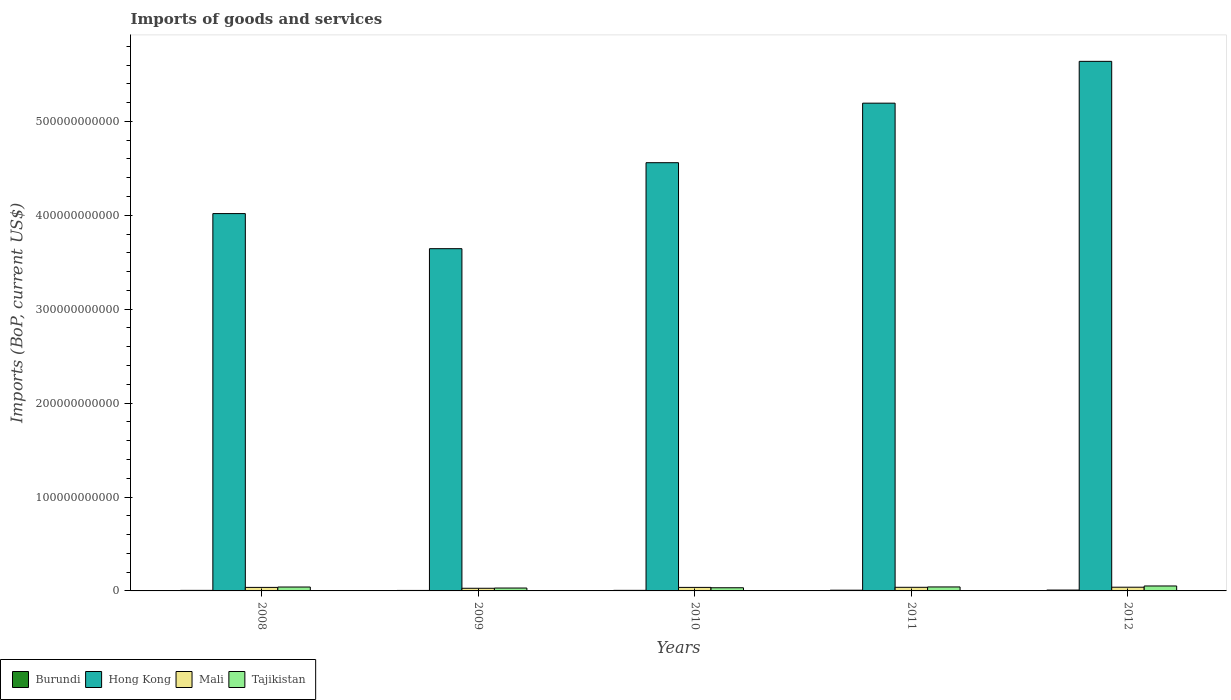How many different coloured bars are there?
Offer a terse response. 4. Are the number of bars on each tick of the X-axis equal?
Offer a very short reply. Yes. How many bars are there on the 4th tick from the left?
Make the answer very short. 4. How many bars are there on the 5th tick from the right?
Provide a short and direct response. 4. What is the amount spent on imports in Hong Kong in 2008?
Offer a terse response. 4.02e+11. Across all years, what is the maximum amount spent on imports in Mali?
Offer a terse response. 3.95e+09. Across all years, what is the minimum amount spent on imports in Hong Kong?
Give a very brief answer. 3.64e+11. What is the total amount spent on imports in Hong Kong in the graph?
Offer a terse response. 2.31e+12. What is the difference between the amount spent on imports in Burundi in 2008 and that in 2011?
Ensure brevity in your answer.  -1.71e+08. What is the difference between the amount spent on imports in Mali in 2008 and the amount spent on imports in Hong Kong in 2010?
Give a very brief answer. -4.52e+11. What is the average amount spent on imports in Mali per year?
Provide a succinct answer. 3.62e+09. In the year 2008, what is the difference between the amount spent on imports in Mali and amount spent on imports in Hong Kong?
Your answer should be compact. -3.98e+11. What is the ratio of the amount spent on imports in Burundi in 2008 to that in 2009?
Offer a terse response. 1.14. Is the difference between the amount spent on imports in Mali in 2010 and 2012 greater than the difference between the amount spent on imports in Hong Kong in 2010 and 2012?
Ensure brevity in your answer.  Yes. What is the difference between the highest and the second highest amount spent on imports in Mali?
Keep it short and to the point. 1.03e+08. What is the difference between the highest and the lowest amount spent on imports in Hong Kong?
Give a very brief answer. 1.99e+11. In how many years, is the amount spent on imports in Mali greater than the average amount spent on imports in Mali taken over all years?
Provide a short and direct response. 4. Is the sum of the amount spent on imports in Hong Kong in 2009 and 2010 greater than the maximum amount spent on imports in Tajikistan across all years?
Your answer should be compact. Yes. Is it the case that in every year, the sum of the amount spent on imports in Tajikistan and amount spent on imports in Mali is greater than the sum of amount spent on imports in Burundi and amount spent on imports in Hong Kong?
Make the answer very short. No. What does the 4th bar from the left in 2011 represents?
Provide a short and direct response. Tajikistan. What does the 4th bar from the right in 2011 represents?
Your answer should be very brief. Burundi. How many bars are there?
Offer a very short reply. 20. Are all the bars in the graph horizontal?
Provide a short and direct response. No. What is the difference between two consecutive major ticks on the Y-axis?
Your response must be concise. 1.00e+11. Does the graph contain grids?
Your answer should be compact. No. What is the title of the graph?
Provide a succinct answer. Imports of goods and services. What is the label or title of the Y-axis?
Offer a very short reply. Imports (BoP, current US$). What is the Imports (BoP, current US$) in Burundi in 2008?
Your response must be concise. 5.94e+08. What is the Imports (BoP, current US$) in Hong Kong in 2008?
Your answer should be compact. 4.02e+11. What is the Imports (BoP, current US$) of Mali in 2008?
Offer a terse response. 3.76e+09. What is the Imports (BoP, current US$) of Tajikistan in 2008?
Your answer should be compact. 4.15e+09. What is the Imports (BoP, current US$) in Burundi in 2009?
Ensure brevity in your answer.  5.20e+08. What is the Imports (BoP, current US$) in Hong Kong in 2009?
Provide a succinct answer. 3.64e+11. What is the Imports (BoP, current US$) in Mali in 2009?
Give a very brief answer. 2.81e+09. What is the Imports (BoP, current US$) in Tajikistan in 2009?
Offer a terse response. 3.06e+09. What is the Imports (BoP, current US$) of Burundi in 2010?
Your answer should be compact. 6.07e+08. What is the Imports (BoP, current US$) in Hong Kong in 2010?
Your answer should be very brief. 4.56e+11. What is the Imports (BoP, current US$) of Mali in 2010?
Make the answer very short. 3.74e+09. What is the Imports (BoP, current US$) in Tajikistan in 2010?
Make the answer very short. 3.36e+09. What is the Imports (BoP, current US$) in Burundi in 2011?
Ensure brevity in your answer.  7.65e+08. What is the Imports (BoP, current US$) in Hong Kong in 2011?
Your answer should be compact. 5.19e+11. What is the Imports (BoP, current US$) of Mali in 2011?
Your response must be concise. 3.85e+09. What is the Imports (BoP, current US$) in Tajikistan in 2011?
Provide a succinct answer. 4.24e+09. What is the Imports (BoP, current US$) in Burundi in 2012?
Your answer should be very brief. 9.23e+08. What is the Imports (BoP, current US$) in Hong Kong in 2012?
Keep it short and to the point. 5.64e+11. What is the Imports (BoP, current US$) in Mali in 2012?
Provide a short and direct response. 3.95e+09. What is the Imports (BoP, current US$) of Tajikistan in 2012?
Provide a succinct answer. 5.27e+09. Across all years, what is the maximum Imports (BoP, current US$) in Burundi?
Provide a short and direct response. 9.23e+08. Across all years, what is the maximum Imports (BoP, current US$) of Hong Kong?
Your answer should be compact. 5.64e+11. Across all years, what is the maximum Imports (BoP, current US$) in Mali?
Offer a terse response. 3.95e+09. Across all years, what is the maximum Imports (BoP, current US$) in Tajikistan?
Keep it short and to the point. 5.27e+09. Across all years, what is the minimum Imports (BoP, current US$) of Burundi?
Your answer should be very brief. 5.20e+08. Across all years, what is the minimum Imports (BoP, current US$) in Hong Kong?
Give a very brief answer. 3.64e+11. Across all years, what is the minimum Imports (BoP, current US$) of Mali?
Your answer should be very brief. 2.81e+09. Across all years, what is the minimum Imports (BoP, current US$) of Tajikistan?
Offer a very short reply. 3.06e+09. What is the total Imports (BoP, current US$) of Burundi in the graph?
Your answer should be very brief. 3.41e+09. What is the total Imports (BoP, current US$) of Hong Kong in the graph?
Your answer should be compact. 2.31e+12. What is the total Imports (BoP, current US$) of Mali in the graph?
Ensure brevity in your answer.  1.81e+1. What is the total Imports (BoP, current US$) of Tajikistan in the graph?
Offer a very short reply. 2.01e+1. What is the difference between the Imports (BoP, current US$) in Burundi in 2008 and that in 2009?
Offer a terse response. 7.46e+07. What is the difference between the Imports (BoP, current US$) of Hong Kong in 2008 and that in 2009?
Keep it short and to the point. 3.74e+1. What is the difference between the Imports (BoP, current US$) in Mali in 2008 and that in 2009?
Ensure brevity in your answer.  9.45e+08. What is the difference between the Imports (BoP, current US$) in Tajikistan in 2008 and that in 2009?
Ensure brevity in your answer.  1.09e+09. What is the difference between the Imports (BoP, current US$) of Burundi in 2008 and that in 2010?
Ensure brevity in your answer.  -1.25e+07. What is the difference between the Imports (BoP, current US$) of Hong Kong in 2008 and that in 2010?
Make the answer very short. -5.42e+1. What is the difference between the Imports (BoP, current US$) of Mali in 2008 and that in 2010?
Provide a succinct answer. 1.23e+07. What is the difference between the Imports (BoP, current US$) in Tajikistan in 2008 and that in 2010?
Your answer should be very brief. 7.90e+08. What is the difference between the Imports (BoP, current US$) in Burundi in 2008 and that in 2011?
Offer a terse response. -1.71e+08. What is the difference between the Imports (BoP, current US$) of Hong Kong in 2008 and that in 2011?
Offer a terse response. -1.18e+11. What is the difference between the Imports (BoP, current US$) of Mali in 2008 and that in 2011?
Your answer should be compact. -9.39e+07. What is the difference between the Imports (BoP, current US$) in Tajikistan in 2008 and that in 2011?
Provide a short and direct response. -8.48e+07. What is the difference between the Imports (BoP, current US$) in Burundi in 2008 and that in 2012?
Offer a very short reply. -3.28e+08. What is the difference between the Imports (BoP, current US$) in Hong Kong in 2008 and that in 2012?
Offer a very short reply. -1.62e+11. What is the difference between the Imports (BoP, current US$) in Mali in 2008 and that in 2012?
Your answer should be compact. -1.97e+08. What is the difference between the Imports (BoP, current US$) in Tajikistan in 2008 and that in 2012?
Provide a succinct answer. -1.12e+09. What is the difference between the Imports (BoP, current US$) in Burundi in 2009 and that in 2010?
Keep it short and to the point. -8.71e+07. What is the difference between the Imports (BoP, current US$) of Hong Kong in 2009 and that in 2010?
Offer a very short reply. -9.16e+1. What is the difference between the Imports (BoP, current US$) of Mali in 2009 and that in 2010?
Make the answer very short. -9.33e+08. What is the difference between the Imports (BoP, current US$) of Tajikistan in 2009 and that in 2010?
Ensure brevity in your answer.  -3.02e+08. What is the difference between the Imports (BoP, current US$) of Burundi in 2009 and that in 2011?
Offer a terse response. -2.46e+08. What is the difference between the Imports (BoP, current US$) in Hong Kong in 2009 and that in 2011?
Your response must be concise. -1.55e+11. What is the difference between the Imports (BoP, current US$) in Mali in 2009 and that in 2011?
Offer a terse response. -1.04e+09. What is the difference between the Imports (BoP, current US$) in Tajikistan in 2009 and that in 2011?
Make the answer very short. -1.18e+09. What is the difference between the Imports (BoP, current US$) in Burundi in 2009 and that in 2012?
Offer a very short reply. -4.03e+08. What is the difference between the Imports (BoP, current US$) of Hong Kong in 2009 and that in 2012?
Keep it short and to the point. -1.99e+11. What is the difference between the Imports (BoP, current US$) of Mali in 2009 and that in 2012?
Your answer should be very brief. -1.14e+09. What is the difference between the Imports (BoP, current US$) in Tajikistan in 2009 and that in 2012?
Your answer should be very brief. -2.21e+09. What is the difference between the Imports (BoP, current US$) of Burundi in 2010 and that in 2011?
Your response must be concise. -1.59e+08. What is the difference between the Imports (BoP, current US$) in Hong Kong in 2010 and that in 2011?
Give a very brief answer. -6.34e+1. What is the difference between the Imports (BoP, current US$) in Mali in 2010 and that in 2011?
Offer a terse response. -1.06e+08. What is the difference between the Imports (BoP, current US$) in Tajikistan in 2010 and that in 2011?
Your answer should be very brief. -8.75e+08. What is the difference between the Imports (BoP, current US$) in Burundi in 2010 and that in 2012?
Your response must be concise. -3.16e+08. What is the difference between the Imports (BoP, current US$) of Hong Kong in 2010 and that in 2012?
Give a very brief answer. -1.08e+11. What is the difference between the Imports (BoP, current US$) in Mali in 2010 and that in 2012?
Give a very brief answer. -2.09e+08. What is the difference between the Imports (BoP, current US$) of Tajikistan in 2010 and that in 2012?
Provide a short and direct response. -1.91e+09. What is the difference between the Imports (BoP, current US$) of Burundi in 2011 and that in 2012?
Your answer should be compact. -1.57e+08. What is the difference between the Imports (BoP, current US$) of Hong Kong in 2011 and that in 2012?
Your response must be concise. -4.45e+1. What is the difference between the Imports (BoP, current US$) of Mali in 2011 and that in 2012?
Provide a short and direct response. -1.03e+08. What is the difference between the Imports (BoP, current US$) in Tajikistan in 2011 and that in 2012?
Provide a short and direct response. -1.03e+09. What is the difference between the Imports (BoP, current US$) in Burundi in 2008 and the Imports (BoP, current US$) in Hong Kong in 2009?
Your answer should be compact. -3.64e+11. What is the difference between the Imports (BoP, current US$) of Burundi in 2008 and the Imports (BoP, current US$) of Mali in 2009?
Provide a succinct answer. -2.22e+09. What is the difference between the Imports (BoP, current US$) of Burundi in 2008 and the Imports (BoP, current US$) of Tajikistan in 2009?
Ensure brevity in your answer.  -2.47e+09. What is the difference between the Imports (BoP, current US$) in Hong Kong in 2008 and the Imports (BoP, current US$) in Mali in 2009?
Give a very brief answer. 3.99e+11. What is the difference between the Imports (BoP, current US$) in Hong Kong in 2008 and the Imports (BoP, current US$) in Tajikistan in 2009?
Provide a succinct answer. 3.99e+11. What is the difference between the Imports (BoP, current US$) in Mali in 2008 and the Imports (BoP, current US$) in Tajikistan in 2009?
Offer a very short reply. 6.95e+08. What is the difference between the Imports (BoP, current US$) in Burundi in 2008 and the Imports (BoP, current US$) in Hong Kong in 2010?
Make the answer very short. -4.55e+11. What is the difference between the Imports (BoP, current US$) in Burundi in 2008 and the Imports (BoP, current US$) in Mali in 2010?
Give a very brief answer. -3.15e+09. What is the difference between the Imports (BoP, current US$) in Burundi in 2008 and the Imports (BoP, current US$) in Tajikistan in 2010?
Keep it short and to the point. -2.77e+09. What is the difference between the Imports (BoP, current US$) in Hong Kong in 2008 and the Imports (BoP, current US$) in Mali in 2010?
Your answer should be compact. 3.98e+11. What is the difference between the Imports (BoP, current US$) of Hong Kong in 2008 and the Imports (BoP, current US$) of Tajikistan in 2010?
Offer a terse response. 3.98e+11. What is the difference between the Imports (BoP, current US$) of Mali in 2008 and the Imports (BoP, current US$) of Tajikistan in 2010?
Give a very brief answer. 3.93e+08. What is the difference between the Imports (BoP, current US$) in Burundi in 2008 and the Imports (BoP, current US$) in Hong Kong in 2011?
Ensure brevity in your answer.  -5.19e+11. What is the difference between the Imports (BoP, current US$) of Burundi in 2008 and the Imports (BoP, current US$) of Mali in 2011?
Ensure brevity in your answer.  -3.26e+09. What is the difference between the Imports (BoP, current US$) of Burundi in 2008 and the Imports (BoP, current US$) of Tajikistan in 2011?
Make the answer very short. -3.65e+09. What is the difference between the Imports (BoP, current US$) of Hong Kong in 2008 and the Imports (BoP, current US$) of Mali in 2011?
Provide a short and direct response. 3.98e+11. What is the difference between the Imports (BoP, current US$) of Hong Kong in 2008 and the Imports (BoP, current US$) of Tajikistan in 2011?
Give a very brief answer. 3.98e+11. What is the difference between the Imports (BoP, current US$) of Mali in 2008 and the Imports (BoP, current US$) of Tajikistan in 2011?
Provide a succinct answer. -4.82e+08. What is the difference between the Imports (BoP, current US$) of Burundi in 2008 and the Imports (BoP, current US$) of Hong Kong in 2012?
Offer a very short reply. -5.63e+11. What is the difference between the Imports (BoP, current US$) in Burundi in 2008 and the Imports (BoP, current US$) in Mali in 2012?
Provide a succinct answer. -3.36e+09. What is the difference between the Imports (BoP, current US$) of Burundi in 2008 and the Imports (BoP, current US$) of Tajikistan in 2012?
Offer a very short reply. -4.68e+09. What is the difference between the Imports (BoP, current US$) in Hong Kong in 2008 and the Imports (BoP, current US$) in Mali in 2012?
Give a very brief answer. 3.98e+11. What is the difference between the Imports (BoP, current US$) of Hong Kong in 2008 and the Imports (BoP, current US$) of Tajikistan in 2012?
Keep it short and to the point. 3.97e+11. What is the difference between the Imports (BoP, current US$) in Mali in 2008 and the Imports (BoP, current US$) in Tajikistan in 2012?
Keep it short and to the point. -1.52e+09. What is the difference between the Imports (BoP, current US$) of Burundi in 2009 and the Imports (BoP, current US$) of Hong Kong in 2010?
Make the answer very short. -4.55e+11. What is the difference between the Imports (BoP, current US$) in Burundi in 2009 and the Imports (BoP, current US$) in Mali in 2010?
Your response must be concise. -3.23e+09. What is the difference between the Imports (BoP, current US$) in Burundi in 2009 and the Imports (BoP, current US$) in Tajikistan in 2010?
Your answer should be compact. -2.84e+09. What is the difference between the Imports (BoP, current US$) in Hong Kong in 2009 and the Imports (BoP, current US$) in Mali in 2010?
Keep it short and to the point. 3.61e+11. What is the difference between the Imports (BoP, current US$) of Hong Kong in 2009 and the Imports (BoP, current US$) of Tajikistan in 2010?
Your answer should be compact. 3.61e+11. What is the difference between the Imports (BoP, current US$) in Mali in 2009 and the Imports (BoP, current US$) in Tajikistan in 2010?
Offer a terse response. -5.53e+08. What is the difference between the Imports (BoP, current US$) of Burundi in 2009 and the Imports (BoP, current US$) of Hong Kong in 2011?
Ensure brevity in your answer.  -5.19e+11. What is the difference between the Imports (BoP, current US$) of Burundi in 2009 and the Imports (BoP, current US$) of Mali in 2011?
Offer a very short reply. -3.33e+09. What is the difference between the Imports (BoP, current US$) of Burundi in 2009 and the Imports (BoP, current US$) of Tajikistan in 2011?
Ensure brevity in your answer.  -3.72e+09. What is the difference between the Imports (BoP, current US$) in Hong Kong in 2009 and the Imports (BoP, current US$) in Mali in 2011?
Keep it short and to the point. 3.61e+11. What is the difference between the Imports (BoP, current US$) of Hong Kong in 2009 and the Imports (BoP, current US$) of Tajikistan in 2011?
Give a very brief answer. 3.60e+11. What is the difference between the Imports (BoP, current US$) in Mali in 2009 and the Imports (BoP, current US$) in Tajikistan in 2011?
Keep it short and to the point. -1.43e+09. What is the difference between the Imports (BoP, current US$) in Burundi in 2009 and the Imports (BoP, current US$) in Hong Kong in 2012?
Give a very brief answer. -5.63e+11. What is the difference between the Imports (BoP, current US$) in Burundi in 2009 and the Imports (BoP, current US$) in Mali in 2012?
Your answer should be very brief. -3.43e+09. What is the difference between the Imports (BoP, current US$) of Burundi in 2009 and the Imports (BoP, current US$) of Tajikistan in 2012?
Your answer should be compact. -4.75e+09. What is the difference between the Imports (BoP, current US$) in Hong Kong in 2009 and the Imports (BoP, current US$) in Mali in 2012?
Your answer should be very brief. 3.60e+11. What is the difference between the Imports (BoP, current US$) in Hong Kong in 2009 and the Imports (BoP, current US$) in Tajikistan in 2012?
Offer a very short reply. 3.59e+11. What is the difference between the Imports (BoP, current US$) of Mali in 2009 and the Imports (BoP, current US$) of Tajikistan in 2012?
Offer a terse response. -2.46e+09. What is the difference between the Imports (BoP, current US$) of Burundi in 2010 and the Imports (BoP, current US$) of Hong Kong in 2011?
Give a very brief answer. -5.19e+11. What is the difference between the Imports (BoP, current US$) in Burundi in 2010 and the Imports (BoP, current US$) in Mali in 2011?
Provide a short and direct response. -3.24e+09. What is the difference between the Imports (BoP, current US$) in Burundi in 2010 and the Imports (BoP, current US$) in Tajikistan in 2011?
Your answer should be compact. -3.63e+09. What is the difference between the Imports (BoP, current US$) of Hong Kong in 2010 and the Imports (BoP, current US$) of Mali in 2011?
Provide a succinct answer. 4.52e+11. What is the difference between the Imports (BoP, current US$) in Hong Kong in 2010 and the Imports (BoP, current US$) in Tajikistan in 2011?
Your answer should be very brief. 4.52e+11. What is the difference between the Imports (BoP, current US$) in Mali in 2010 and the Imports (BoP, current US$) in Tajikistan in 2011?
Make the answer very short. -4.95e+08. What is the difference between the Imports (BoP, current US$) in Burundi in 2010 and the Imports (BoP, current US$) in Hong Kong in 2012?
Provide a short and direct response. -5.63e+11. What is the difference between the Imports (BoP, current US$) of Burundi in 2010 and the Imports (BoP, current US$) of Mali in 2012?
Make the answer very short. -3.35e+09. What is the difference between the Imports (BoP, current US$) of Burundi in 2010 and the Imports (BoP, current US$) of Tajikistan in 2012?
Make the answer very short. -4.67e+09. What is the difference between the Imports (BoP, current US$) of Hong Kong in 2010 and the Imports (BoP, current US$) of Mali in 2012?
Provide a short and direct response. 4.52e+11. What is the difference between the Imports (BoP, current US$) in Hong Kong in 2010 and the Imports (BoP, current US$) in Tajikistan in 2012?
Your response must be concise. 4.51e+11. What is the difference between the Imports (BoP, current US$) of Mali in 2010 and the Imports (BoP, current US$) of Tajikistan in 2012?
Offer a terse response. -1.53e+09. What is the difference between the Imports (BoP, current US$) of Burundi in 2011 and the Imports (BoP, current US$) of Hong Kong in 2012?
Provide a short and direct response. -5.63e+11. What is the difference between the Imports (BoP, current US$) in Burundi in 2011 and the Imports (BoP, current US$) in Mali in 2012?
Ensure brevity in your answer.  -3.19e+09. What is the difference between the Imports (BoP, current US$) of Burundi in 2011 and the Imports (BoP, current US$) of Tajikistan in 2012?
Your answer should be very brief. -4.51e+09. What is the difference between the Imports (BoP, current US$) in Hong Kong in 2011 and the Imports (BoP, current US$) in Mali in 2012?
Your response must be concise. 5.15e+11. What is the difference between the Imports (BoP, current US$) of Hong Kong in 2011 and the Imports (BoP, current US$) of Tajikistan in 2012?
Your answer should be compact. 5.14e+11. What is the difference between the Imports (BoP, current US$) in Mali in 2011 and the Imports (BoP, current US$) in Tajikistan in 2012?
Your response must be concise. -1.42e+09. What is the average Imports (BoP, current US$) of Burundi per year?
Provide a succinct answer. 6.82e+08. What is the average Imports (BoP, current US$) in Hong Kong per year?
Your response must be concise. 4.61e+11. What is the average Imports (BoP, current US$) of Mali per year?
Keep it short and to the point. 3.62e+09. What is the average Imports (BoP, current US$) of Tajikistan per year?
Keep it short and to the point. 4.02e+09. In the year 2008, what is the difference between the Imports (BoP, current US$) of Burundi and Imports (BoP, current US$) of Hong Kong?
Your answer should be very brief. -4.01e+11. In the year 2008, what is the difference between the Imports (BoP, current US$) of Burundi and Imports (BoP, current US$) of Mali?
Offer a very short reply. -3.16e+09. In the year 2008, what is the difference between the Imports (BoP, current US$) in Burundi and Imports (BoP, current US$) in Tajikistan?
Your answer should be compact. -3.56e+09. In the year 2008, what is the difference between the Imports (BoP, current US$) of Hong Kong and Imports (BoP, current US$) of Mali?
Provide a succinct answer. 3.98e+11. In the year 2008, what is the difference between the Imports (BoP, current US$) in Hong Kong and Imports (BoP, current US$) in Tajikistan?
Make the answer very short. 3.98e+11. In the year 2008, what is the difference between the Imports (BoP, current US$) in Mali and Imports (BoP, current US$) in Tajikistan?
Offer a very short reply. -3.97e+08. In the year 2009, what is the difference between the Imports (BoP, current US$) in Burundi and Imports (BoP, current US$) in Hong Kong?
Your answer should be compact. -3.64e+11. In the year 2009, what is the difference between the Imports (BoP, current US$) in Burundi and Imports (BoP, current US$) in Mali?
Ensure brevity in your answer.  -2.29e+09. In the year 2009, what is the difference between the Imports (BoP, current US$) of Burundi and Imports (BoP, current US$) of Tajikistan?
Keep it short and to the point. -2.54e+09. In the year 2009, what is the difference between the Imports (BoP, current US$) in Hong Kong and Imports (BoP, current US$) in Mali?
Keep it short and to the point. 3.62e+11. In the year 2009, what is the difference between the Imports (BoP, current US$) of Hong Kong and Imports (BoP, current US$) of Tajikistan?
Your answer should be very brief. 3.61e+11. In the year 2009, what is the difference between the Imports (BoP, current US$) of Mali and Imports (BoP, current US$) of Tajikistan?
Offer a very short reply. -2.50e+08. In the year 2010, what is the difference between the Imports (BoP, current US$) of Burundi and Imports (BoP, current US$) of Hong Kong?
Your answer should be compact. -4.55e+11. In the year 2010, what is the difference between the Imports (BoP, current US$) in Burundi and Imports (BoP, current US$) in Mali?
Provide a succinct answer. -3.14e+09. In the year 2010, what is the difference between the Imports (BoP, current US$) in Burundi and Imports (BoP, current US$) in Tajikistan?
Make the answer very short. -2.76e+09. In the year 2010, what is the difference between the Imports (BoP, current US$) in Hong Kong and Imports (BoP, current US$) in Mali?
Make the answer very short. 4.52e+11. In the year 2010, what is the difference between the Imports (BoP, current US$) of Hong Kong and Imports (BoP, current US$) of Tajikistan?
Your answer should be compact. 4.53e+11. In the year 2010, what is the difference between the Imports (BoP, current US$) of Mali and Imports (BoP, current US$) of Tajikistan?
Offer a very short reply. 3.80e+08. In the year 2011, what is the difference between the Imports (BoP, current US$) in Burundi and Imports (BoP, current US$) in Hong Kong?
Your response must be concise. -5.19e+11. In the year 2011, what is the difference between the Imports (BoP, current US$) in Burundi and Imports (BoP, current US$) in Mali?
Keep it short and to the point. -3.09e+09. In the year 2011, what is the difference between the Imports (BoP, current US$) in Burundi and Imports (BoP, current US$) in Tajikistan?
Offer a very short reply. -3.47e+09. In the year 2011, what is the difference between the Imports (BoP, current US$) of Hong Kong and Imports (BoP, current US$) of Mali?
Provide a succinct answer. 5.16e+11. In the year 2011, what is the difference between the Imports (BoP, current US$) of Hong Kong and Imports (BoP, current US$) of Tajikistan?
Your answer should be very brief. 5.15e+11. In the year 2011, what is the difference between the Imports (BoP, current US$) in Mali and Imports (BoP, current US$) in Tajikistan?
Provide a short and direct response. -3.88e+08. In the year 2012, what is the difference between the Imports (BoP, current US$) in Burundi and Imports (BoP, current US$) in Hong Kong?
Your answer should be very brief. -5.63e+11. In the year 2012, what is the difference between the Imports (BoP, current US$) of Burundi and Imports (BoP, current US$) of Mali?
Your answer should be very brief. -3.03e+09. In the year 2012, what is the difference between the Imports (BoP, current US$) in Burundi and Imports (BoP, current US$) in Tajikistan?
Keep it short and to the point. -4.35e+09. In the year 2012, what is the difference between the Imports (BoP, current US$) in Hong Kong and Imports (BoP, current US$) in Mali?
Provide a short and direct response. 5.60e+11. In the year 2012, what is the difference between the Imports (BoP, current US$) in Hong Kong and Imports (BoP, current US$) in Tajikistan?
Provide a short and direct response. 5.59e+11. In the year 2012, what is the difference between the Imports (BoP, current US$) of Mali and Imports (BoP, current US$) of Tajikistan?
Offer a terse response. -1.32e+09. What is the ratio of the Imports (BoP, current US$) of Burundi in 2008 to that in 2009?
Ensure brevity in your answer.  1.14. What is the ratio of the Imports (BoP, current US$) of Hong Kong in 2008 to that in 2009?
Your response must be concise. 1.1. What is the ratio of the Imports (BoP, current US$) of Mali in 2008 to that in 2009?
Give a very brief answer. 1.34. What is the ratio of the Imports (BoP, current US$) of Tajikistan in 2008 to that in 2009?
Your response must be concise. 1.36. What is the ratio of the Imports (BoP, current US$) of Burundi in 2008 to that in 2010?
Make the answer very short. 0.98. What is the ratio of the Imports (BoP, current US$) of Hong Kong in 2008 to that in 2010?
Ensure brevity in your answer.  0.88. What is the ratio of the Imports (BoP, current US$) in Tajikistan in 2008 to that in 2010?
Your answer should be compact. 1.23. What is the ratio of the Imports (BoP, current US$) of Burundi in 2008 to that in 2011?
Your answer should be compact. 0.78. What is the ratio of the Imports (BoP, current US$) of Hong Kong in 2008 to that in 2011?
Your answer should be compact. 0.77. What is the ratio of the Imports (BoP, current US$) of Mali in 2008 to that in 2011?
Your response must be concise. 0.98. What is the ratio of the Imports (BoP, current US$) in Burundi in 2008 to that in 2012?
Make the answer very short. 0.64. What is the ratio of the Imports (BoP, current US$) of Hong Kong in 2008 to that in 2012?
Your answer should be very brief. 0.71. What is the ratio of the Imports (BoP, current US$) in Mali in 2008 to that in 2012?
Your answer should be very brief. 0.95. What is the ratio of the Imports (BoP, current US$) in Tajikistan in 2008 to that in 2012?
Your response must be concise. 0.79. What is the ratio of the Imports (BoP, current US$) in Burundi in 2009 to that in 2010?
Keep it short and to the point. 0.86. What is the ratio of the Imports (BoP, current US$) in Hong Kong in 2009 to that in 2010?
Offer a terse response. 0.8. What is the ratio of the Imports (BoP, current US$) of Mali in 2009 to that in 2010?
Your answer should be compact. 0.75. What is the ratio of the Imports (BoP, current US$) of Tajikistan in 2009 to that in 2010?
Provide a short and direct response. 0.91. What is the ratio of the Imports (BoP, current US$) in Burundi in 2009 to that in 2011?
Provide a short and direct response. 0.68. What is the ratio of the Imports (BoP, current US$) in Hong Kong in 2009 to that in 2011?
Your response must be concise. 0.7. What is the ratio of the Imports (BoP, current US$) of Mali in 2009 to that in 2011?
Provide a succinct answer. 0.73. What is the ratio of the Imports (BoP, current US$) of Tajikistan in 2009 to that in 2011?
Provide a short and direct response. 0.72. What is the ratio of the Imports (BoP, current US$) of Burundi in 2009 to that in 2012?
Your answer should be compact. 0.56. What is the ratio of the Imports (BoP, current US$) in Hong Kong in 2009 to that in 2012?
Make the answer very short. 0.65. What is the ratio of the Imports (BoP, current US$) in Mali in 2009 to that in 2012?
Provide a succinct answer. 0.71. What is the ratio of the Imports (BoP, current US$) of Tajikistan in 2009 to that in 2012?
Offer a very short reply. 0.58. What is the ratio of the Imports (BoP, current US$) in Burundi in 2010 to that in 2011?
Offer a terse response. 0.79. What is the ratio of the Imports (BoP, current US$) in Hong Kong in 2010 to that in 2011?
Your answer should be very brief. 0.88. What is the ratio of the Imports (BoP, current US$) in Mali in 2010 to that in 2011?
Make the answer very short. 0.97. What is the ratio of the Imports (BoP, current US$) of Tajikistan in 2010 to that in 2011?
Make the answer very short. 0.79. What is the ratio of the Imports (BoP, current US$) of Burundi in 2010 to that in 2012?
Keep it short and to the point. 0.66. What is the ratio of the Imports (BoP, current US$) of Hong Kong in 2010 to that in 2012?
Ensure brevity in your answer.  0.81. What is the ratio of the Imports (BoP, current US$) in Mali in 2010 to that in 2012?
Offer a terse response. 0.95. What is the ratio of the Imports (BoP, current US$) in Tajikistan in 2010 to that in 2012?
Offer a very short reply. 0.64. What is the ratio of the Imports (BoP, current US$) in Burundi in 2011 to that in 2012?
Provide a short and direct response. 0.83. What is the ratio of the Imports (BoP, current US$) in Hong Kong in 2011 to that in 2012?
Offer a terse response. 0.92. What is the ratio of the Imports (BoP, current US$) of Mali in 2011 to that in 2012?
Your response must be concise. 0.97. What is the ratio of the Imports (BoP, current US$) of Tajikistan in 2011 to that in 2012?
Make the answer very short. 0.8. What is the difference between the highest and the second highest Imports (BoP, current US$) of Burundi?
Keep it short and to the point. 1.57e+08. What is the difference between the highest and the second highest Imports (BoP, current US$) in Hong Kong?
Provide a short and direct response. 4.45e+1. What is the difference between the highest and the second highest Imports (BoP, current US$) in Mali?
Give a very brief answer. 1.03e+08. What is the difference between the highest and the second highest Imports (BoP, current US$) of Tajikistan?
Your answer should be very brief. 1.03e+09. What is the difference between the highest and the lowest Imports (BoP, current US$) of Burundi?
Give a very brief answer. 4.03e+08. What is the difference between the highest and the lowest Imports (BoP, current US$) in Hong Kong?
Provide a short and direct response. 1.99e+11. What is the difference between the highest and the lowest Imports (BoP, current US$) of Mali?
Offer a terse response. 1.14e+09. What is the difference between the highest and the lowest Imports (BoP, current US$) of Tajikistan?
Offer a very short reply. 2.21e+09. 